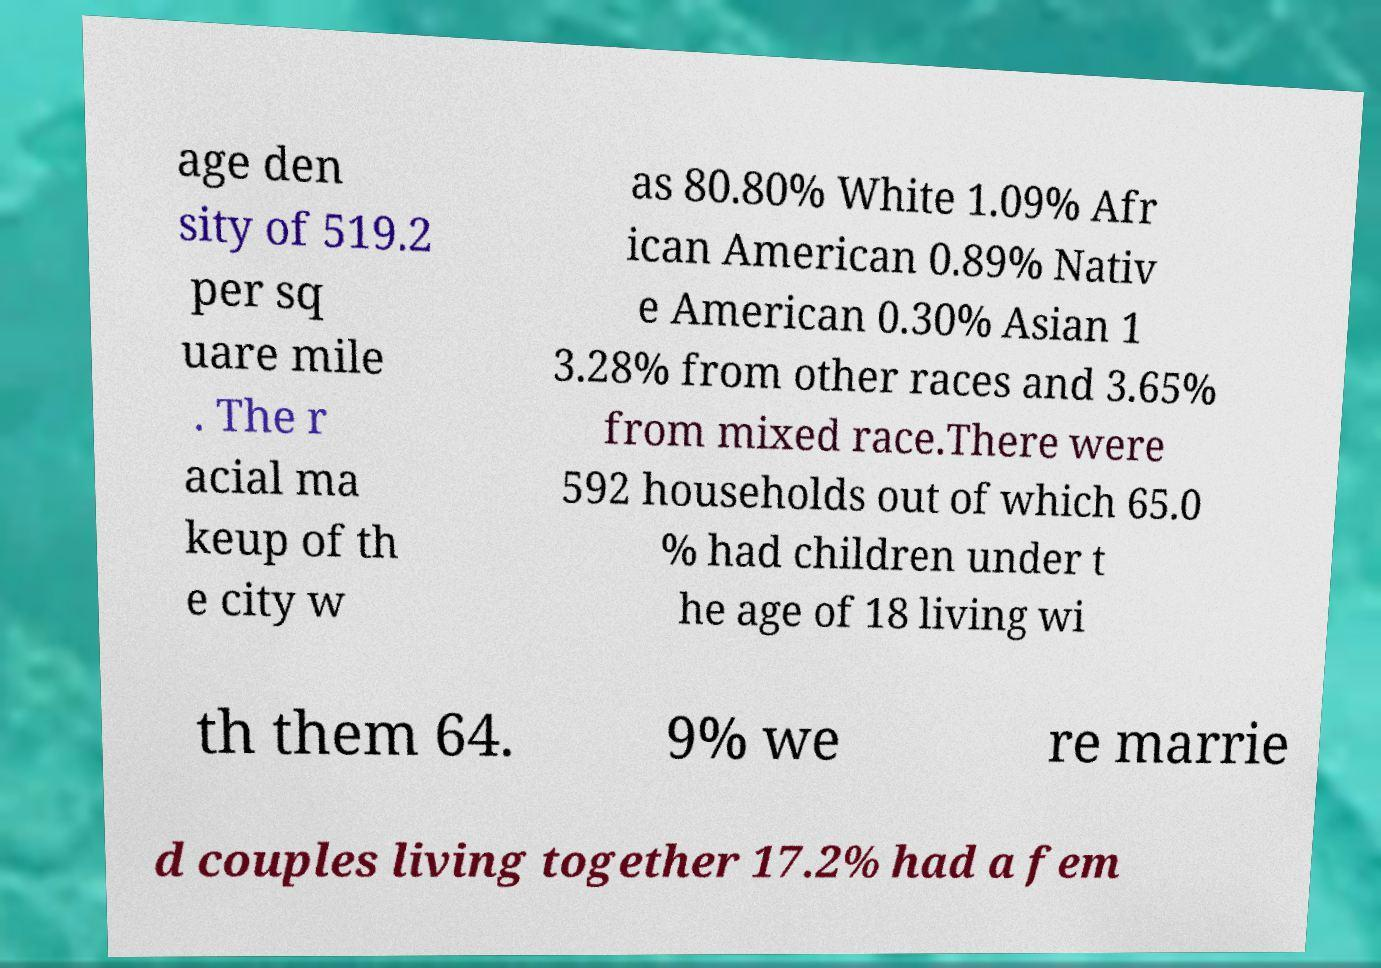Please identify and transcribe the text found in this image. age den sity of 519.2 per sq uare mile . The r acial ma keup of th e city w as 80.80% White 1.09% Afr ican American 0.89% Nativ e American 0.30% Asian 1 3.28% from other races and 3.65% from mixed race.There were 592 households out of which 65.0 % had children under t he age of 18 living wi th them 64. 9% we re marrie d couples living together 17.2% had a fem 